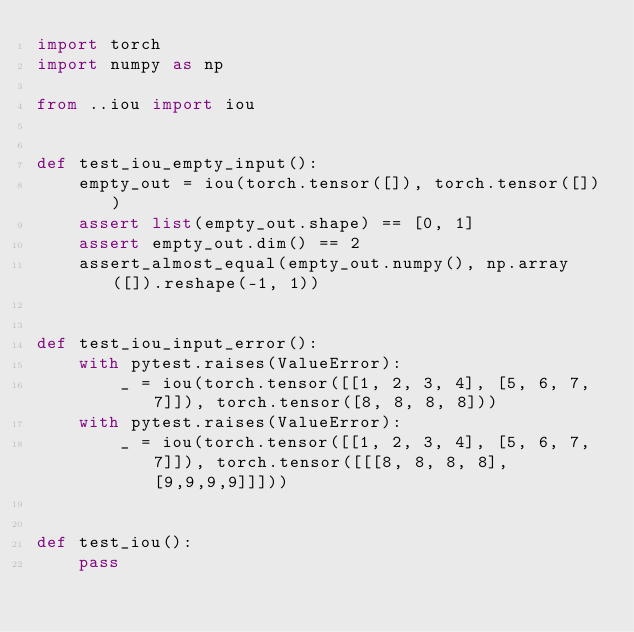<code> <loc_0><loc_0><loc_500><loc_500><_Python_>import torch
import numpy as np

from ..iou import iou


def test_iou_empty_input():
    empty_out = iou(torch.tensor([]), torch.tensor([]))
    assert list(empty_out.shape) == [0, 1]
    assert empty_out.dim() == 2
    assert_almost_equal(empty_out.numpy(), np.array([]).reshape(-1, 1))


def test_iou_input_error():
    with pytest.raises(ValueError):
        _ = iou(torch.tensor([[1, 2, 3, 4], [5, 6, 7, 7]]), torch.tensor([8, 8, 8, 8]))
    with pytest.raises(ValueError):
        _ = iou(torch.tensor([[1, 2, 3, 4], [5, 6, 7, 7]]), torch.tensor([[[8, 8, 8, 8], [9,9,9,9]]]))


def test_iou():
    pass
</code> 